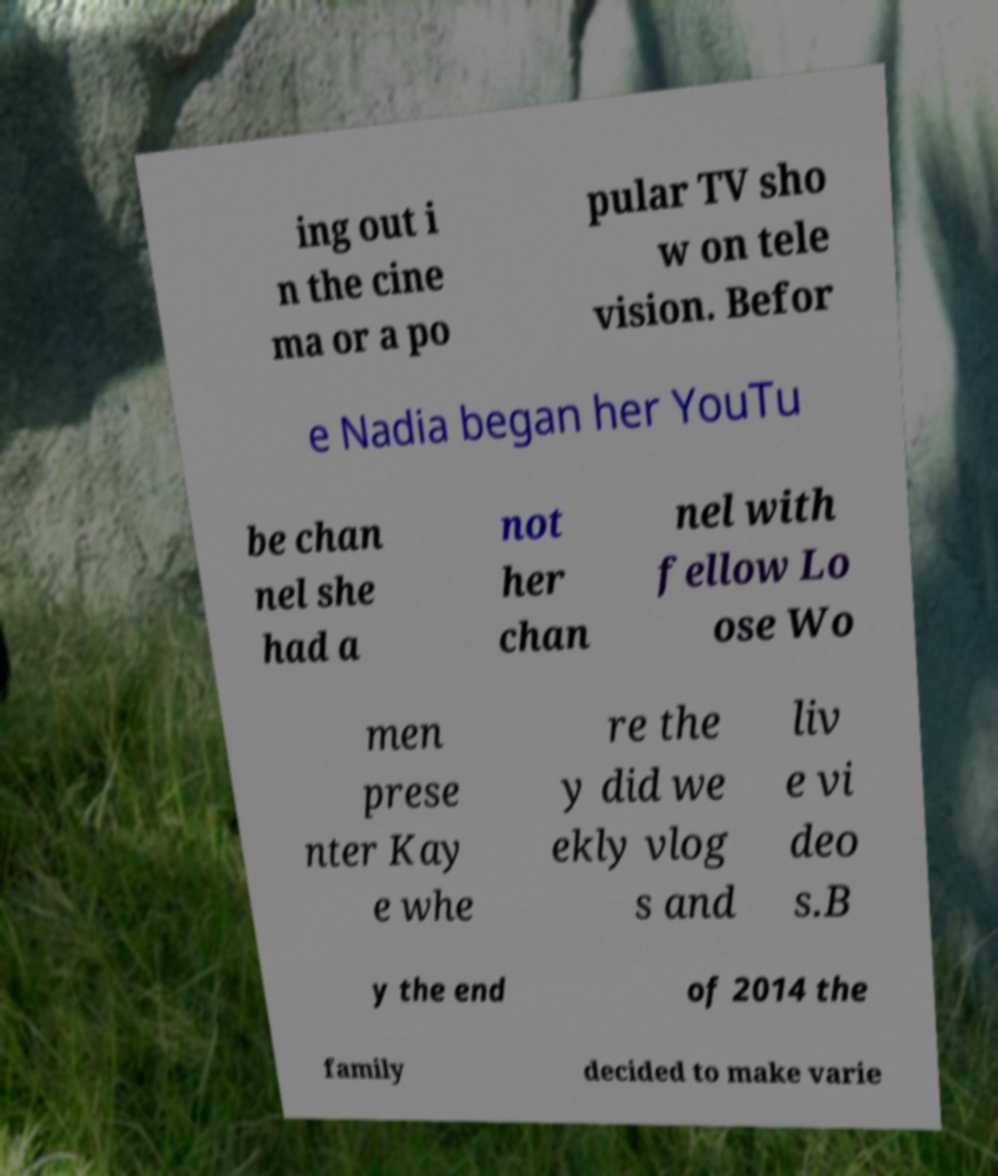I need the written content from this picture converted into text. Can you do that? ing out i n the cine ma or a po pular TV sho w on tele vision. Befor e Nadia began her YouTu be chan nel she had a not her chan nel with fellow Lo ose Wo men prese nter Kay e whe re the y did we ekly vlog s and liv e vi deo s.B y the end of 2014 the family decided to make varie 